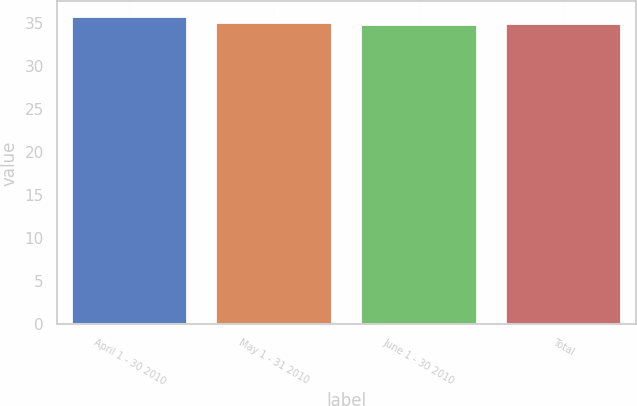<chart> <loc_0><loc_0><loc_500><loc_500><bar_chart><fcel>April 1 - 30 2010<fcel>May 1 - 31 2010<fcel>June 1 - 30 2010<fcel>Total<nl><fcel>35.68<fcel>34.92<fcel>34.72<fcel>34.82<nl></chart> 